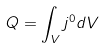<formula> <loc_0><loc_0><loc_500><loc_500>Q = \int _ { V } j ^ { 0 } d V</formula> 